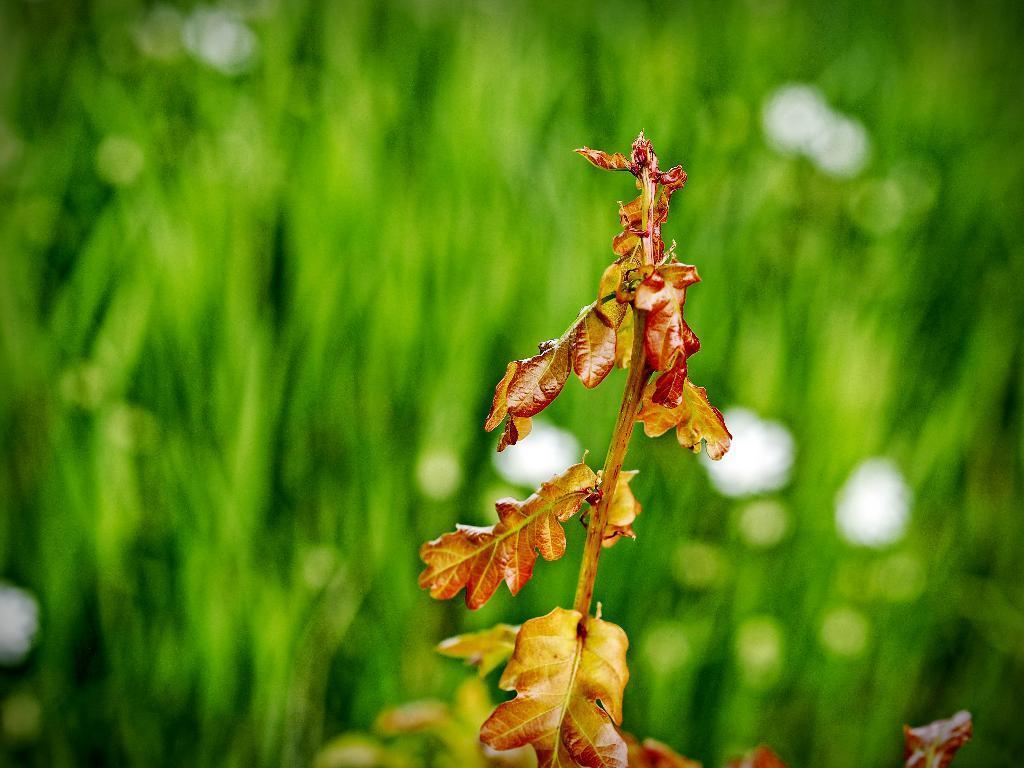Could you give a brief overview of what you see in this image? In this image I can see a tree to which there are orange colored leaves. In the background I can see few trees which are green in color. 